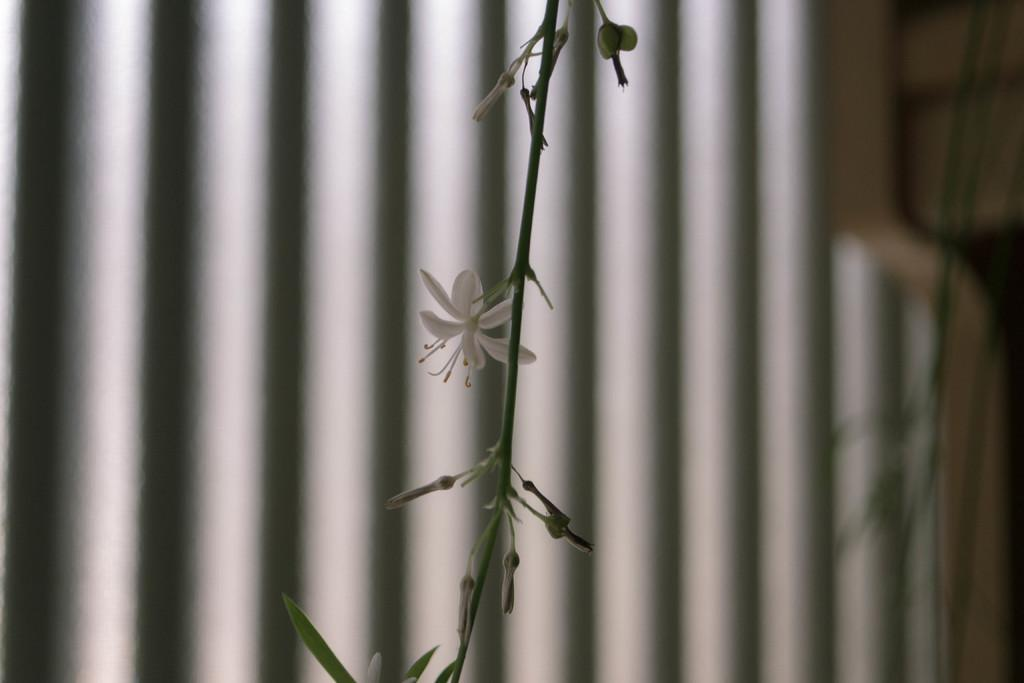What type of plant life is present in the image? There are flowers, buds, leaves, and a stem in the image. Can you describe the growth stages of the plants in the image? The image shows both buds and flowers, indicating different stages of growth. What is visible in the background of the image? The background of the image is blurry, and there are rods visible. How many birds are performing an action on the flowers in the image? There are no birds present in the image, so it is not possible to answer that question. 